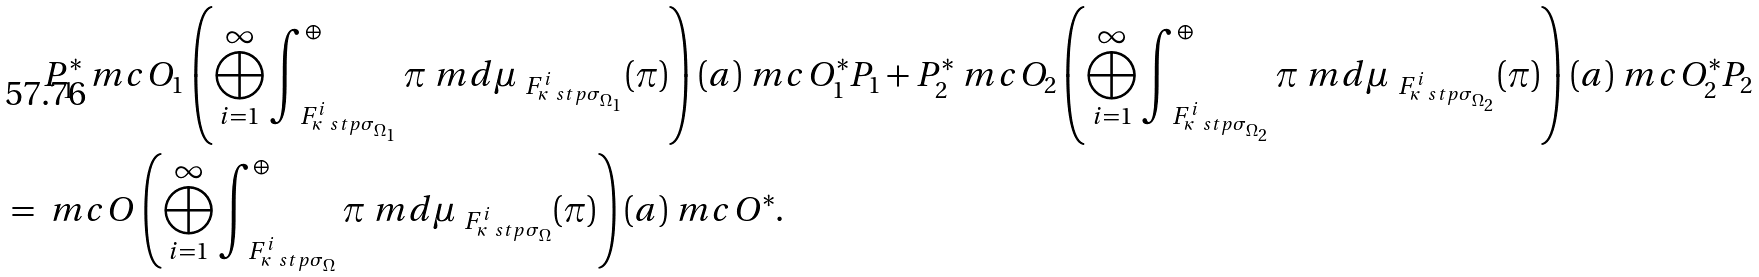<formula> <loc_0><loc_0><loc_500><loc_500>& \quad \, P _ { 1 } ^ { * } \ m c { O } _ { 1 } \left ( \bigoplus _ { i = 1 } ^ { \infty } \int _ { \ F ^ { i } _ { \kappa \ s t p \sigma _ { \Omega _ { 1 } } } } ^ { \oplus } \pi \ m d \mu _ { \ F ^ { i } _ { \kappa \ s t p \sigma _ { \Omega _ { 1 } } } } ( \pi ) \right ) ( a ) \ m c { O } _ { 1 } ^ { * } P _ { 1 } + P _ { 2 } ^ { * } \ m c { O } _ { 2 } \left ( \bigoplus _ { i = 1 } ^ { \infty } \int _ { \ F ^ { i } _ { \kappa \ s t p \sigma _ { \Omega _ { 2 } } } } ^ { \oplus } \pi \ m d \mu _ { \ F ^ { i } _ { \kappa \ s t p \sigma _ { \Omega _ { 2 } } } } ( \pi ) \right ) ( a ) \ m c { O } _ { 2 } ^ { * } P _ { 2 } \\ & = \ m c { O } \left ( \bigoplus _ { i = 1 } ^ { \infty } \int _ { \ F ^ { i } _ { \kappa \ s t p \sigma _ { \Omega } } } ^ { \oplus } \pi \ m d \mu _ { \ F ^ { i } _ { \kappa \ s t p \sigma _ { \Omega } } } ( \pi ) \right ) ( a ) \ m c { O } ^ { * } .</formula> 